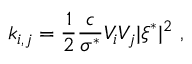<formula> <loc_0><loc_0><loc_500><loc_500>k _ { i , j } = \frac { 1 } { 2 } \frac { c } { \sigma ^ { * } } V _ { i } V _ { j } | \xi ^ { * } | ^ { 2 } \ ,</formula> 